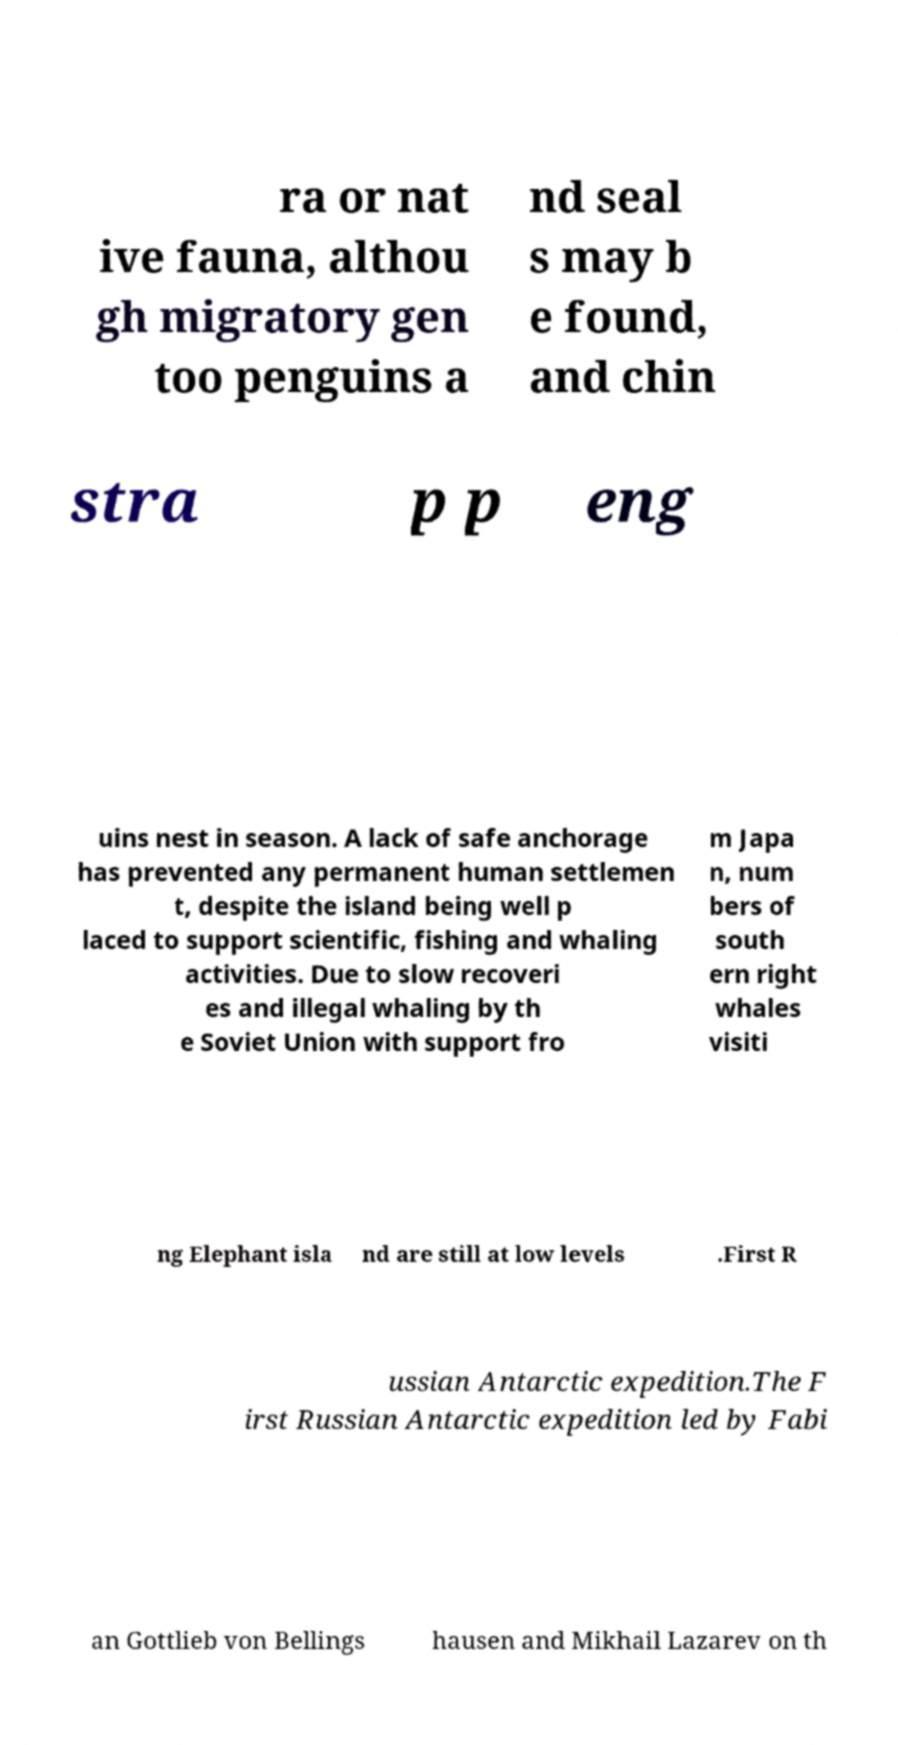There's text embedded in this image that I need extracted. Can you transcribe it verbatim? ra or nat ive fauna, althou gh migratory gen too penguins a nd seal s may b e found, and chin stra p p eng uins nest in season. A lack of safe anchorage has prevented any permanent human settlemen t, despite the island being well p laced to support scientific, fishing and whaling activities. Due to slow recoveri es and illegal whaling by th e Soviet Union with support fro m Japa n, num bers of south ern right whales visiti ng Elephant isla nd are still at low levels .First R ussian Antarctic expedition.The F irst Russian Antarctic expedition led by Fabi an Gottlieb von Bellings hausen and Mikhail Lazarev on th 